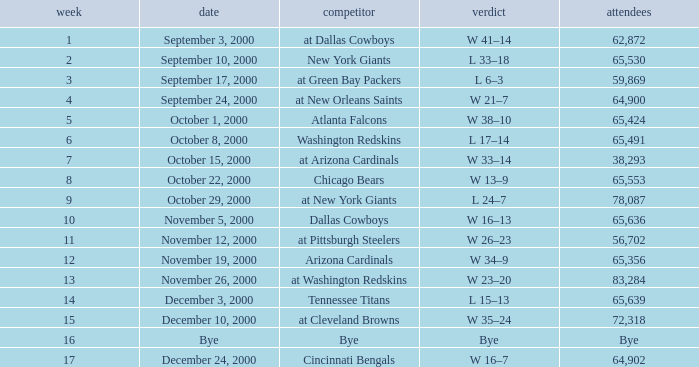What was the attendance for week 2? 65530.0. 